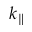<formula> <loc_0><loc_0><loc_500><loc_500>k _ { \| }</formula> 